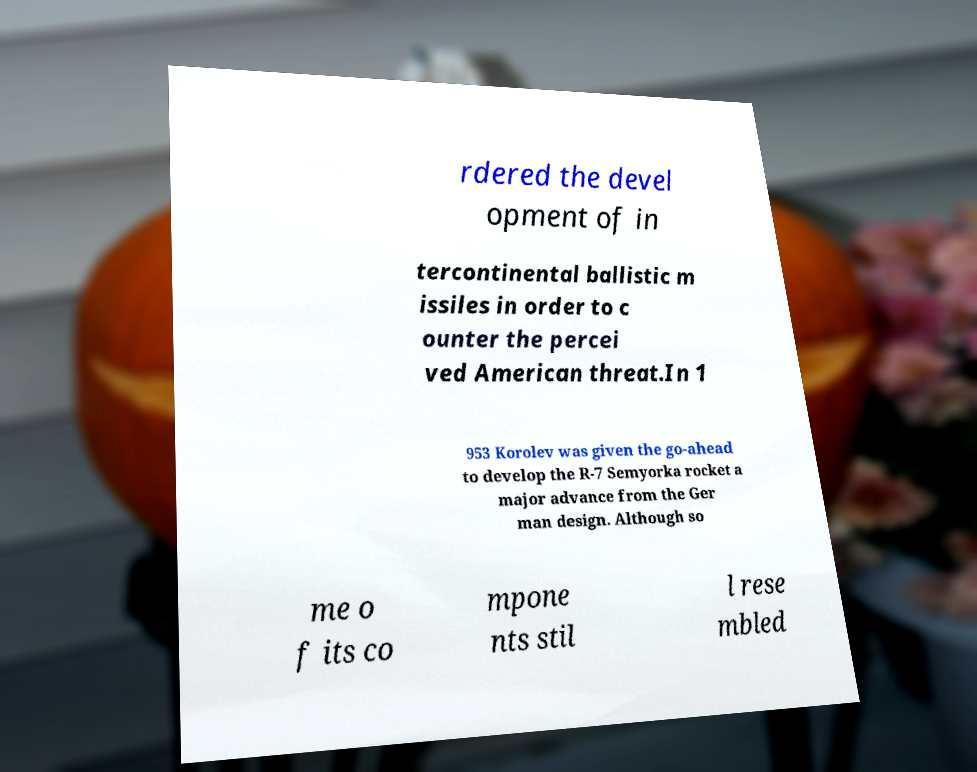What messages or text are displayed in this image? I need them in a readable, typed format. rdered the devel opment of in tercontinental ballistic m issiles in order to c ounter the percei ved American threat.In 1 953 Korolev was given the go-ahead to develop the R-7 Semyorka rocket a major advance from the Ger man design. Although so me o f its co mpone nts stil l rese mbled 